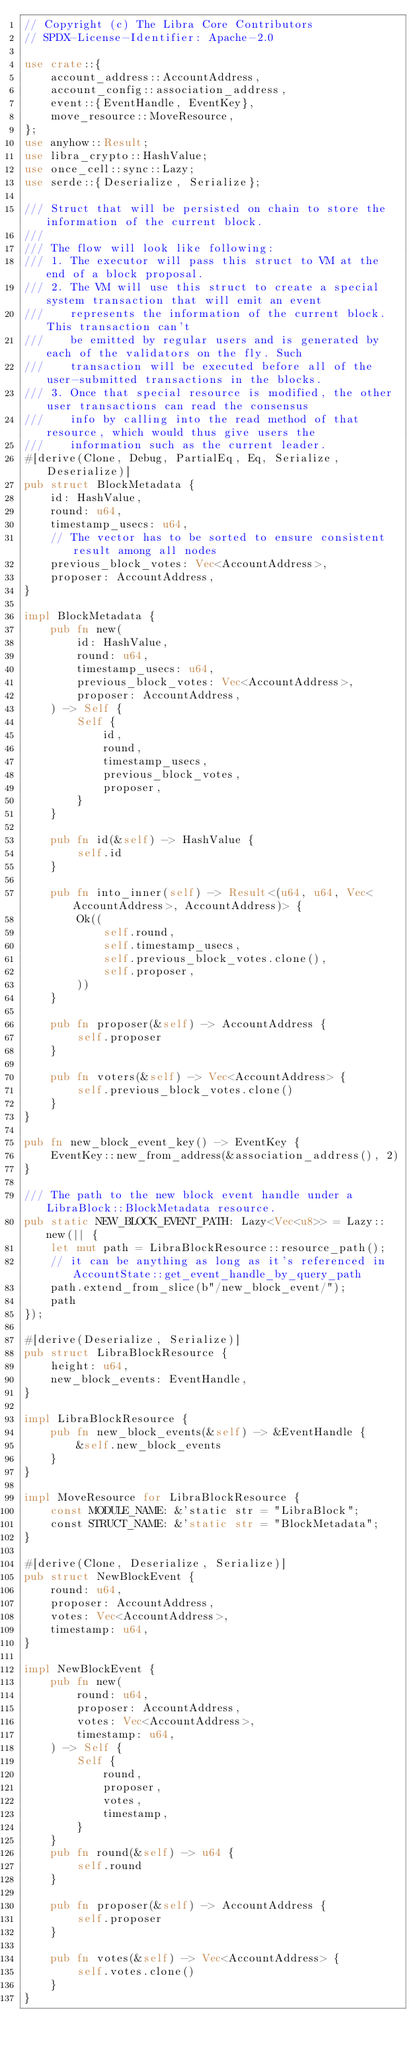<code> <loc_0><loc_0><loc_500><loc_500><_Rust_>// Copyright (c) The Libra Core Contributors
// SPDX-License-Identifier: Apache-2.0

use crate::{
    account_address::AccountAddress,
    account_config::association_address,
    event::{EventHandle, EventKey},
    move_resource::MoveResource,
};
use anyhow::Result;
use libra_crypto::HashValue;
use once_cell::sync::Lazy;
use serde::{Deserialize, Serialize};

/// Struct that will be persisted on chain to store the information of the current block.
///
/// The flow will look like following:
/// 1. The executor will pass this struct to VM at the end of a block proposal.
/// 2. The VM will use this struct to create a special system transaction that will emit an event
///    represents the information of the current block. This transaction can't
///    be emitted by regular users and is generated by each of the validators on the fly. Such
///    transaction will be executed before all of the user-submitted transactions in the blocks.
/// 3. Once that special resource is modified, the other user transactions can read the consensus
///    info by calling into the read method of that resource, which would thus give users the
///    information such as the current leader.
#[derive(Clone, Debug, PartialEq, Eq, Serialize, Deserialize)]
pub struct BlockMetadata {
    id: HashValue,
    round: u64,
    timestamp_usecs: u64,
    // The vector has to be sorted to ensure consistent result among all nodes
    previous_block_votes: Vec<AccountAddress>,
    proposer: AccountAddress,
}

impl BlockMetadata {
    pub fn new(
        id: HashValue,
        round: u64,
        timestamp_usecs: u64,
        previous_block_votes: Vec<AccountAddress>,
        proposer: AccountAddress,
    ) -> Self {
        Self {
            id,
            round,
            timestamp_usecs,
            previous_block_votes,
            proposer,
        }
    }

    pub fn id(&self) -> HashValue {
        self.id
    }

    pub fn into_inner(self) -> Result<(u64, u64, Vec<AccountAddress>, AccountAddress)> {
        Ok((
            self.round,
            self.timestamp_usecs,
            self.previous_block_votes.clone(),
            self.proposer,
        ))
    }

    pub fn proposer(&self) -> AccountAddress {
        self.proposer
    }

    pub fn voters(&self) -> Vec<AccountAddress> {
        self.previous_block_votes.clone()
    }
}

pub fn new_block_event_key() -> EventKey {
    EventKey::new_from_address(&association_address(), 2)
}

/// The path to the new block event handle under a LibraBlock::BlockMetadata resource.
pub static NEW_BLOCK_EVENT_PATH: Lazy<Vec<u8>> = Lazy::new(|| {
    let mut path = LibraBlockResource::resource_path();
    // it can be anything as long as it's referenced in AccountState::get_event_handle_by_query_path
    path.extend_from_slice(b"/new_block_event/");
    path
});

#[derive(Deserialize, Serialize)]
pub struct LibraBlockResource {
    height: u64,
    new_block_events: EventHandle,
}

impl LibraBlockResource {
    pub fn new_block_events(&self) -> &EventHandle {
        &self.new_block_events
    }
}

impl MoveResource for LibraBlockResource {
    const MODULE_NAME: &'static str = "LibraBlock";
    const STRUCT_NAME: &'static str = "BlockMetadata";
}

#[derive(Clone, Deserialize, Serialize)]
pub struct NewBlockEvent {
    round: u64,
    proposer: AccountAddress,
    votes: Vec<AccountAddress>,
    timestamp: u64,
}

impl NewBlockEvent {
    pub fn new(
        round: u64,
        proposer: AccountAddress,
        votes: Vec<AccountAddress>,
        timestamp: u64,
    ) -> Self {
        Self {
            round,
            proposer,
            votes,
            timestamp,
        }
    }
    pub fn round(&self) -> u64 {
        self.round
    }

    pub fn proposer(&self) -> AccountAddress {
        self.proposer
    }

    pub fn votes(&self) -> Vec<AccountAddress> {
        self.votes.clone()
    }
}
</code> 